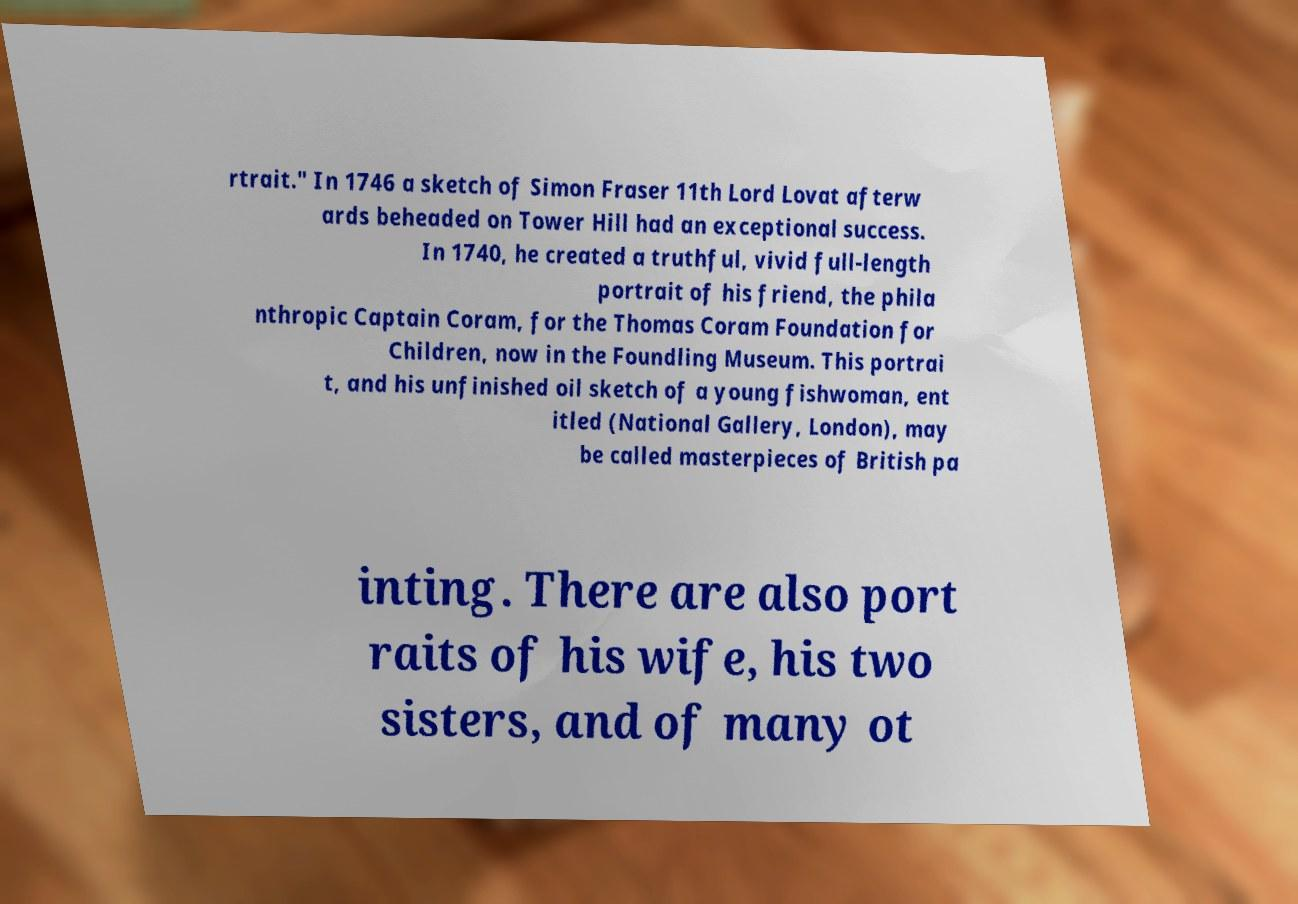I need the written content from this picture converted into text. Can you do that? rtrait." In 1746 a sketch of Simon Fraser 11th Lord Lovat afterw ards beheaded on Tower Hill had an exceptional success. In 1740, he created a truthful, vivid full-length portrait of his friend, the phila nthropic Captain Coram, for the Thomas Coram Foundation for Children, now in the Foundling Museum. This portrai t, and his unfinished oil sketch of a young fishwoman, ent itled (National Gallery, London), may be called masterpieces of British pa inting. There are also port raits of his wife, his two sisters, and of many ot 